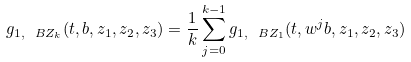<formula> <loc_0><loc_0><loc_500><loc_500>g _ { 1 , \ B Z _ { k } } ( t , b , z _ { 1 } , z _ { 2 } , z _ { 3 } ) = \frac { 1 } { k } \sum _ { j = 0 } ^ { k - 1 } g _ { 1 , \ B Z _ { 1 } } ( t , w ^ { j } b , z _ { 1 } , z _ { 2 } , z _ { 3 } )</formula> 